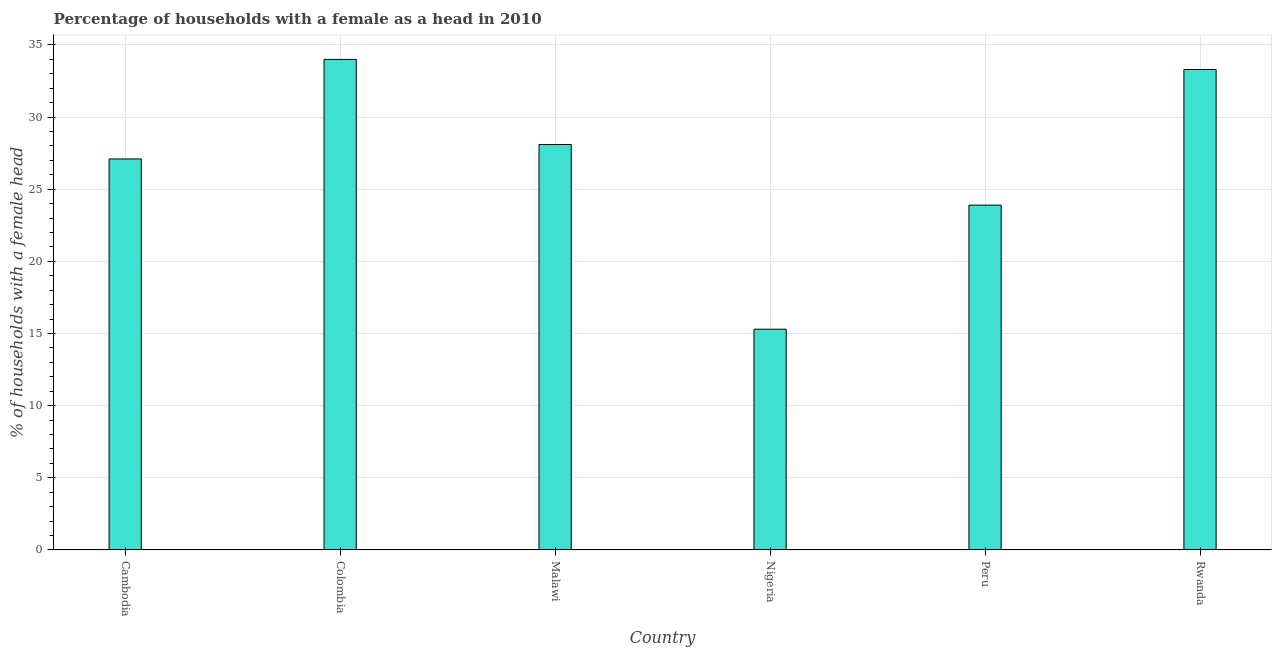Does the graph contain grids?
Offer a very short reply. Yes. What is the title of the graph?
Ensure brevity in your answer.  Percentage of households with a female as a head in 2010. What is the label or title of the Y-axis?
Your answer should be compact. % of households with a female head. What is the number of female supervised households in Nigeria?
Ensure brevity in your answer.  15.3. Across all countries, what is the minimum number of female supervised households?
Ensure brevity in your answer.  15.3. In which country was the number of female supervised households maximum?
Offer a very short reply. Colombia. In which country was the number of female supervised households minimum?
Your answer should be compact. Nigeria. What is the sum of the number of female supervised households?
Offer a very short reply. 161.7. What is the average number of female supervised households per country?
Offer a very short reply. 26.95. What is the median number of female supervised households?
Offer a very short reply. 27.6. In how many countries, is the number of female supervised households greater than 13 %?
Your answer should be very brief. 6. What is the ratio of the number of female supervised households in Colombia to that in Rwanda?
Your response must be concise. 1.02. Is the number of female supervised households in Colombia less than that in Rwanda?
Provide a short and direct response. No. What is the difference between the highest and the second highest number of female supervised households?
Your answer should be very brief. 0.7. Is the sum of the number of female supervised households in Peru and Rwanda greater than the maximum number of female supervised households across all countries?
Offer a terse response. Yes. Are all the bars in the graph horizontal?
Provide a short and direct response. No. Are the values on the major ticks of Y-axis written in scientific E-notation?
Your answer should be compact. No. What is the % of households with a female head of Cambodia?
Make the answer very short. 27.1. What is the % of households with a female head of Colombia?
Your answer should be compact. 34. What is the % of households with a female head in Malawi?
Make the answer very short. 28.1. What is the % of households with a female head in Peru?
Your response must be concise. 23.9. What is the % of households with a female head of Rwanda?
Make the answer very short. 33.3. What is the difference between the % of households with a female head in Cambodia and Colombia?
Make the answer very short. -6.9. What is the difference between the % of households with a female head in Cambodia and Nigeria?
Keep it short and to the point. 11.8. What is the difference between the % of households with a female head in Colombia and Malawi?
Keep it short and to the point. 5.9. What is the difference between the % of households with a female head in Colombia and Nigeria?
Your answer should be very brief. 18.7. What is the difference between the % of households with a female head in Colombia and Peru?
Your answer should be compact. 10.1. What is the difference between the % of households with a female head in Colombia and Rwanda?
Provide a succinct answer. 0.7. What is the difference between the % of households with a female head in Malawi and Nigeria?
Keep it short and to the point. 12.8. What is the difference between the % of households with a female head in Malawi and Peru?
Provide a short and direct response. 4.2. What is the difference between the % of households with a female head in Malawi and Rwanda?
Your response must be concise. -5.2. What is the difference between the % of households with a female head in Nigeria and Peru?
Provide a short and direct response. -8.6. What is the ratio of the % of households with a female head in Cambodia to that in Colombia?
Ensure brevity in your answer.  0.8. What is the ratio of the % of households with a female head in Cambodia to that in Nigeria?
Offer a very short reply. 1.77. What is the ratio of the % of households with a female head in Cambodia to that in Peru?
Provide a short and direct response. 1.13. What is the ratio of the % of households with a female head in Cambodia to that in Rwanda?
Your answer should be very brief. 0.81. What is the ratio of the % of households with a female head in Colombia to that in Malawi?
Make the answer very short. 1.21. What is the ratio of the % of households with a female head in Colombia to that in Nigeria?
Your answer should be compact. 2.22. What is the ratio of the % of households with a female head in Colombia to that in Peru?
Your answer should be very brief. 1.42. What is the ratio of the % of households with a female head in Malawi to that in Nigeria?
Offer a very short reply. 1.84. What is the ratio of the % of households with a female head in Malawi to that in Peru?
Your response must be concise. 1.18. What is the ratio of the % of households with a female head in Malawi to that in Rwanda?
Your response must be concise. 0.84. What is the ratio of the % of households with a female head in Nigeria to that in Peru?
Your response must be concise. 0.64. What is the ratio of the % of households with a female head in Nigeria to that in Rwanda?
Your answer should be very brief. 0.46. What is the ratio of the % of households with a female head in Peru to that in Rwanda?
Provide a succinct answer. 0.72. 